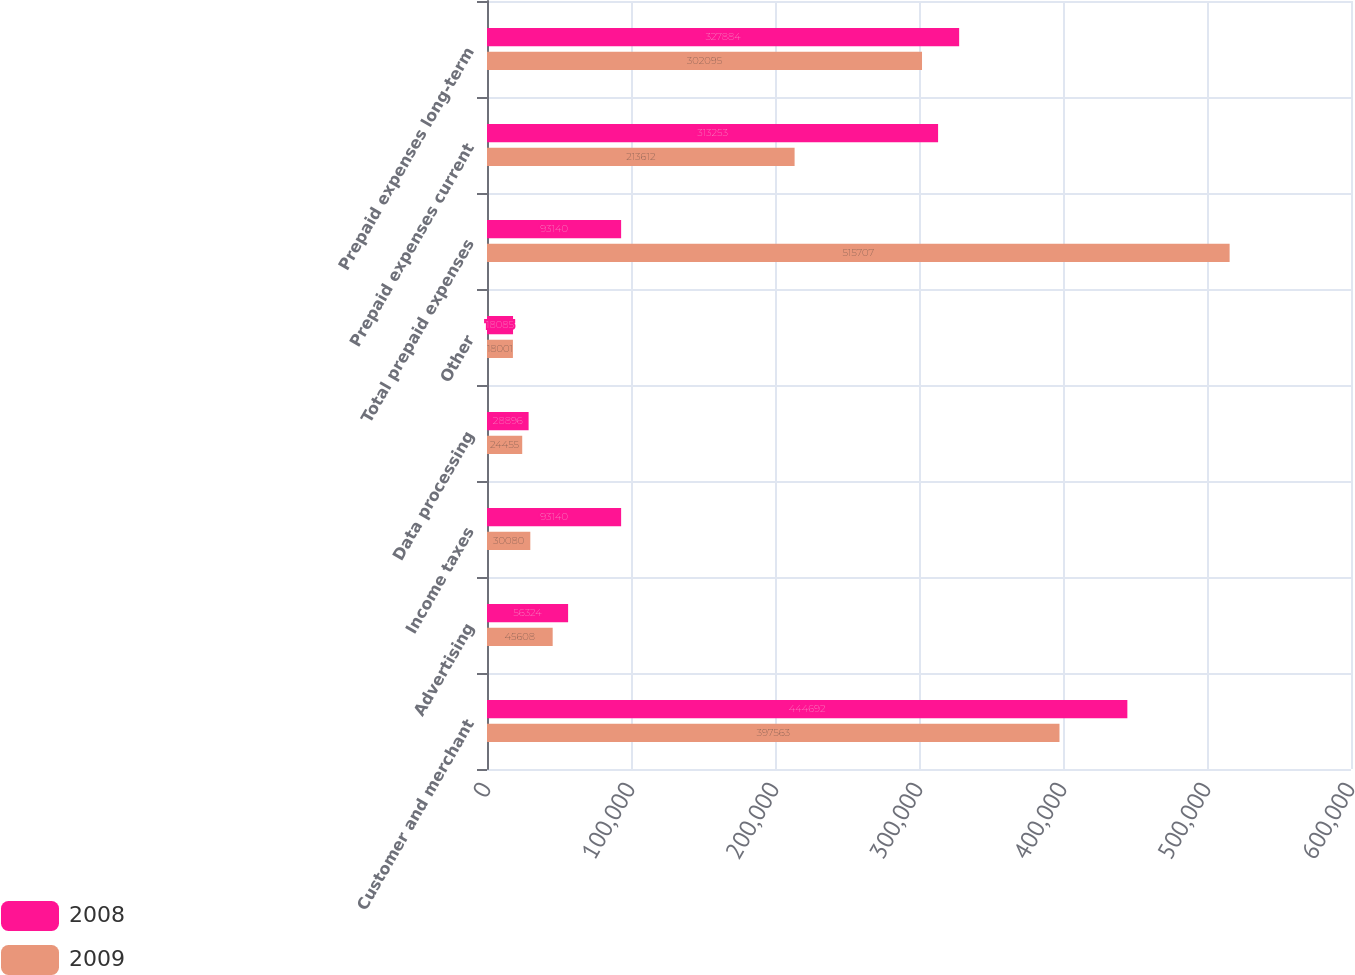Convert chart to OTSL. <chart><loc_0><loc_0><loc_500><loc_500><stacked_bar_chart><ecel><fcel>Customer and merchant<fcel>Advertising<fcel>Income taxes<fcel>Data processing<fcel>Other<fcel>Total prepaid expenses<fcel>Prepaid expenses current<fcel>Prepaid expenses long-term<nl><fcel>2008<fcel>444692<fcel>56324<fcel>93140<fcel>28896<fcel>18085<fcel>93140<fcel>313253<fcel>327884<nl><fcel>2009<fcel>397563<fcel>45608<fcel>30080<fcel>24455<fcel>18001<fcel>515707<fcel>213612<fcel>302095<nl></chart> 